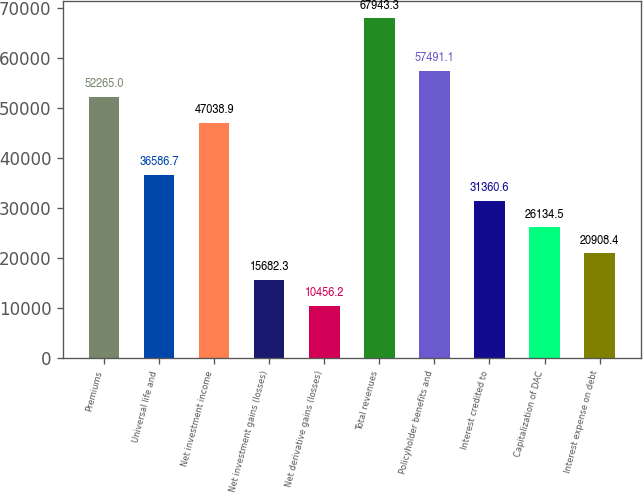<chart> <loc_0><loc_0><loc_500><loc_500><bar_chart><fcel>Premiums<fcel>Universal life and<fcel>Net investment income<fcel>Net investment gains (losses)<fcel>Net derivative gains (losses)<fcel>Total revenues<fcel>Policyholder benefits and<fcel>Interest credited to<fcel>Capitalization of DAC<fcel>Interest expense on debt<nl><fcel>52265<fcel>36586.7<fcel>47038.9<fcel>15682.3<fcel>10456.2<fcel>67943.3<fcel>57491.1<fcel>31360.6<fcel>26134.5<fcel>20908.4<nl></chart> 